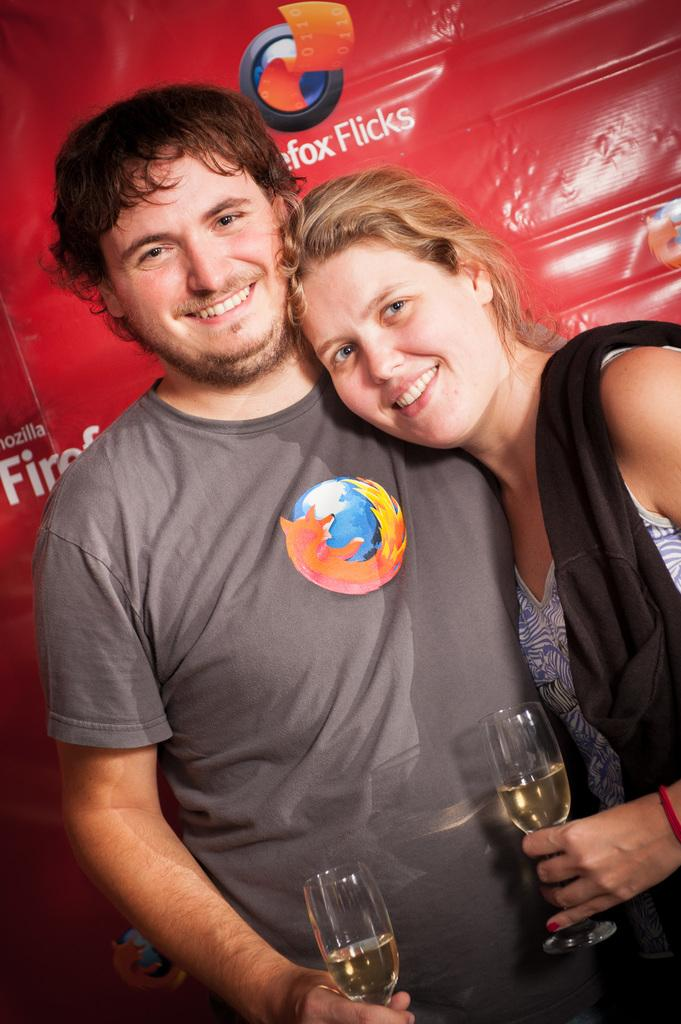Who is present in the image? There is a couple in the image. What are the couple doing in the image? The couple is posing for a camera. What objects are the couple holding in the image? The couple is holding wine glasses. Can you see the coastline in the background of the image? There is no coastline visible in the image; it features a couple posing with wine glasses. 